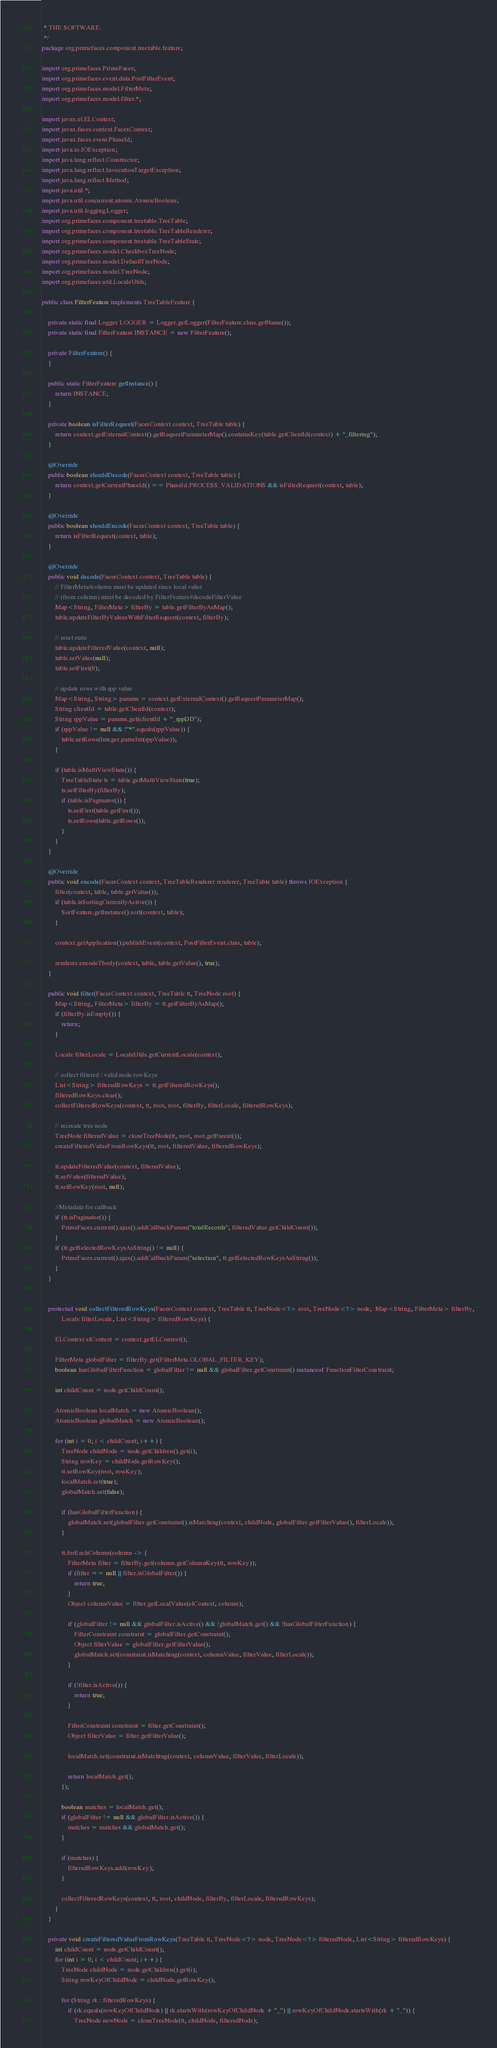Convert code to text. <code><loc_0><loc_0><loc_500><loc_500><_Java_> * THE SOFTWARE.
 */
package org.primefaces.component.treetable.feature;

import org.primefaces.PrimeFaces;
import org.primefaces.event.data.PostFilterEvent;
import org.primefaces.model.FilterMeta;
import org.primefaces.model.filter.*;

import javax.el.ELContext;
import javax.faces.context.FacesContext;
import javax.faces.event.PhaseId;
import java.io.IOException;
import java.lang.reflect.Constructor;
import java.lang.reflect.InvocationTargetException;
import java.lang.reflect.Method;
import java.util.*;
import java.util.concurrent.atomic.AtomicBoolean;
import java.util.logging.Logger;
import org.primefaces.component.treetable.TreeTable;
import org.primefaces.component.treetable.TreeTableRenderer;
import org.primefaces.component.treetable.TreeTableState;
import org.primefaces.model.CheckboxTreeNode;
import org.primefaces.model.DefaultTreeNode;
import org.primefaces.model.TreeNode;
import org.primefaces.util.LocaleUtils;

public class FilterFeature implements TreeTableFeature {

    private static final Logger LOGGER = Logger.getLogger(FilterFeature.class.getName());
    private static final FilterFeature INSTANCE = new FilterFeature();

    private FilterFeature() {
    }

    public static FilterFeature getInstance() {
        return INSTANCE;
    }

    private boolean isFilterRequest(FacesContext context, TreeTable table) {
        return context.getExternalContext().getRequestParameterMap().containsKey(table.getClientId(context) + "_filtering");
    }

    @Override
    public boolean shouldDecode(FacesContext context, TreeTable table) {
        return context.getCurrentPhaseId() == PhaseId.PROCESS_VALIDATIONS && isFilterRequest(context, table);
    }

    @Override
    public boolean shouldEncode(FacesContext context, TreeTable table) {
        return isFilterRequest(context, table);
    }

    @Override
    public void decode(FacesContext context, TreeTable table) {
        // FilterMeta#column must be updated since local value
        // (from column) must be decoded by FilterFeature#decodeFilterValue
        Map<String, FilterMeta> filterBy = table.getFilterByAsMap();
        table.updateFilterByValuesWithFilterRequest(context, filterBy);

        // reset state
        table.updateFilteredValue(context, null);
        table.setValue(null);
        table.setFirst(0);

        // update rows with rpp value
        Map<String, String> params = context.getExternalContext().getRequestParameterMap();
        String clientId = table.getClientId(context);
        String rppValue = params.get(clientId + "_rppDD");
        if (rppValue != null && !"*".equals(rppValue)) {
            table.setRows(Integer.parseInt(rppValue));
        }

        if (table.isMultiViewState()) {
            TreeTableState ts = table.getMultiViewState(true);
            ts.setFilterBy(filterBy);
            if (table.isPaginator()) {
                ts.setFirst(table.getFirst());
                ts.setRows(table.getRows());
            }
        }
    }

    @Override
    public void encode(FacesContext context, TreeTableRenderer renderer, TreeTable table) throws IOException {
        filter(context, table, table.getValue());
        if (table.isSortingCurrentlyActive()) {
            SortFeature.getInstance().sort(context, table);
        }

        context.getApplication().publishEvent(context, PostFilterEvent.class, table);

        renderer.encodeTbody(context, table, table.getValue(), true);
    }

    public void filter(FacesContext context, TreeTable tt, TreeNode root) {
        Map<String, FilterMeta> filterBy = tt.getFilterByAsMap();
        if (filterBy.isEmpty()) {
            return;
        }

        Locale filterLocale = LocaleUtils.getCurrentLocale(context);

        // collect filtered / valid node rowKeys
        List<String> filteredRowKeys = tt.getFilteredRowKeys();
        filteredRowKeys.clear();
        collectFilteredRowKeys(context, tt, root, root, filterBy, filterLocale, filteredRowKeys);

        // recreate tree node
        TreeNode filteredValue = cloneTreeNode(tt, root, root.getParent());
        createFilteredValueFromRowKeys(tt, root, filteredValue, filteredRowKeys);

        tt.updateFilteredValue(context, filteredValue);
        tt.setValue(filteredValue);
        tt.setRowKey(root, null);

        //Metadata for callback
        if (tt.isPaginator()) {
            PrimeFaces.current().ajax().addCallbackParam("totalRecords", filteredValue.getChildCount());
        }
        if (tt.getSelectedRowKeysAsString() != null) {
            PrimeFaces.current().ajax().addCallbackParam("selection", tt.getSelectedRowKeysAsString());
        }
    }


    protected void collectFilteredRowKeys(FacesContext context, TreeTable tt, TreeNode<?> root, TreeNode<?> node,  Map<String, FilterMeta> filterBy,
            Locale filterLocale, List<String> filteredRowKeys) {

        ELContext elContext = context.getELContext();

        FilterMeta globalFilter = filterBy.get(FilterMeta.GLOBAL_FILTER_KEY);
        boolean hasGlobalFilterFunction = globalFilter != null && globalFilter.getConstraint() instanceof FunctionFilterConstraint;

        int childCount = node.getChildCount();

        AtomicBoolean localMatch = new AtomicBoolean();
        AtomicBoolean globalMatch = new AtomicBoolean();

        for (int i = 0; i < childCount; i++) {
            TreeNode childNode = node.getChildren().get(i);
            String rowKey = childNode.getRowKey();
            tt.setRowKey(root, rowKey);
            localMatch.set(true);
            globalMatch.set(false);

            if (hasGlobalFilterFunction) {
                globalMatch.set(globalFilter.getConstraint().isMatching(context, childNode, globalFilter.getFilterValue(), filterLocale));
            }

            tt.forEachColumn(column -> {
                FilterMeta filter = filterBy.get(column.getColumnKey(tt, rowKey));
                if (filter == null || filter.isGlobalFilter()) {
                    return true;
                }
                Object columnValue = filter.getLocalValue(elContext, column);

                if (globalFilter != null && globalFilter.isActive() && !globalMatch.get() && !hasGlobalFilterFunction) {
                    FilterConstraint constraint = globalFilter.getConstraint();
                    Object filterValue = globalFilter.getFilterValue();
                    globalMatch.set(constraint.isMatching(context, columnValue, filterValue, filterLocale));
                }

                if (!filter.isActive()) {
                    return true;
                }

                FilterConstraint constraint = filter.getConstraint();
                Object filterValue = filter.getFilterValue();

                localMatch.set(constraint.isMatching(context, columnValue, filterValue, filterLocale));

                return localMatch.get();
            });

            boolean matches = localMatch.get();
            if (globalFilter != null && globalFilter.isActive()) {
                matches = matches && globalMatch.get();
            }

            if (matches) {
                filteredRowKeys.add(rowKey);
            }

            collectFilteredRowKeys(context, tt, root, childNode, filterBy, filterLocale, filteredRowKeys);
        }
    }

    private void createFilteredValueFromRowKeys(TreeTable tt, TreeNode<?> node, TreeNode<?> filteredNode, List<String> filteredRowKeys) {
        int childCount = node.getChildCount();
        for (int i = 0; i < childCount; i++) {
            TreeNode childNode = node.getChildren().get(i);
            String rowKeyOfChildNode = childNode.getRowKey();

            for (String rk : filteredRowKeys) {
                if (rk.equals(rowKeyOfChildNode) || rk.startsWith(rowKeyOfChildNode + "_") || rowKeyOfChildNode.startsWith(rk + "_")) {
                    TreeNode newNode = cloneTreeNode(tt, childNode, filteredNode);</code> 